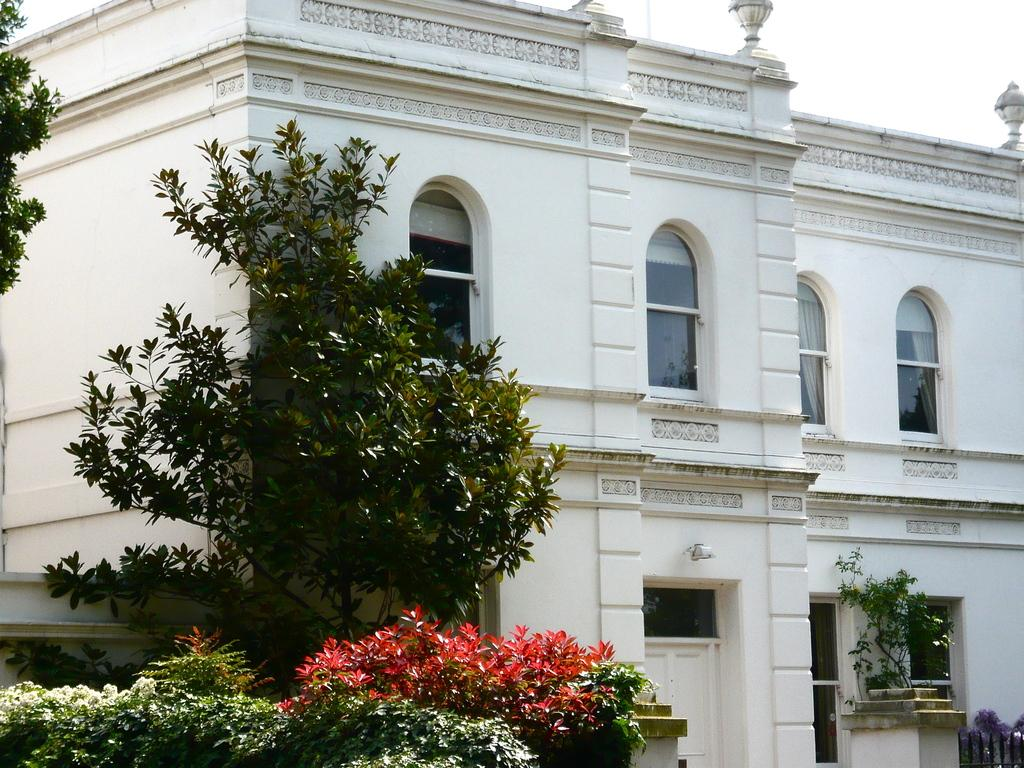What type of structures can be seen in the image? There are buildings in the image. What architectural features can be observed on the buildings? There are windows visible on the buildings. What type of vegetation is on the left side of the image? There are trees and bushes on the left side of the image. What is visible at the top of the image? The sky is visible at the top of the image. Is there a prison visible in the image? No, there is no prison present in the image. What type of peace symbol can be seen in the image? There is no peace symbol present in the image. 